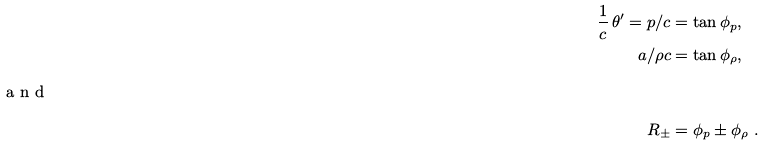<formula> <loc_0><loc_0><loc_500><loc_500>\frac { 1 } { c } \, \theta ^ { \prime } = p / c & = \tan \phi _ { p } , \\ a / \rho c & = \tan \phi _ { \rho } , \\ \intertext { a n d } R _ { \pm } & = \phi _ { p } \pm \phi _ { \rho } \ .</formula> 